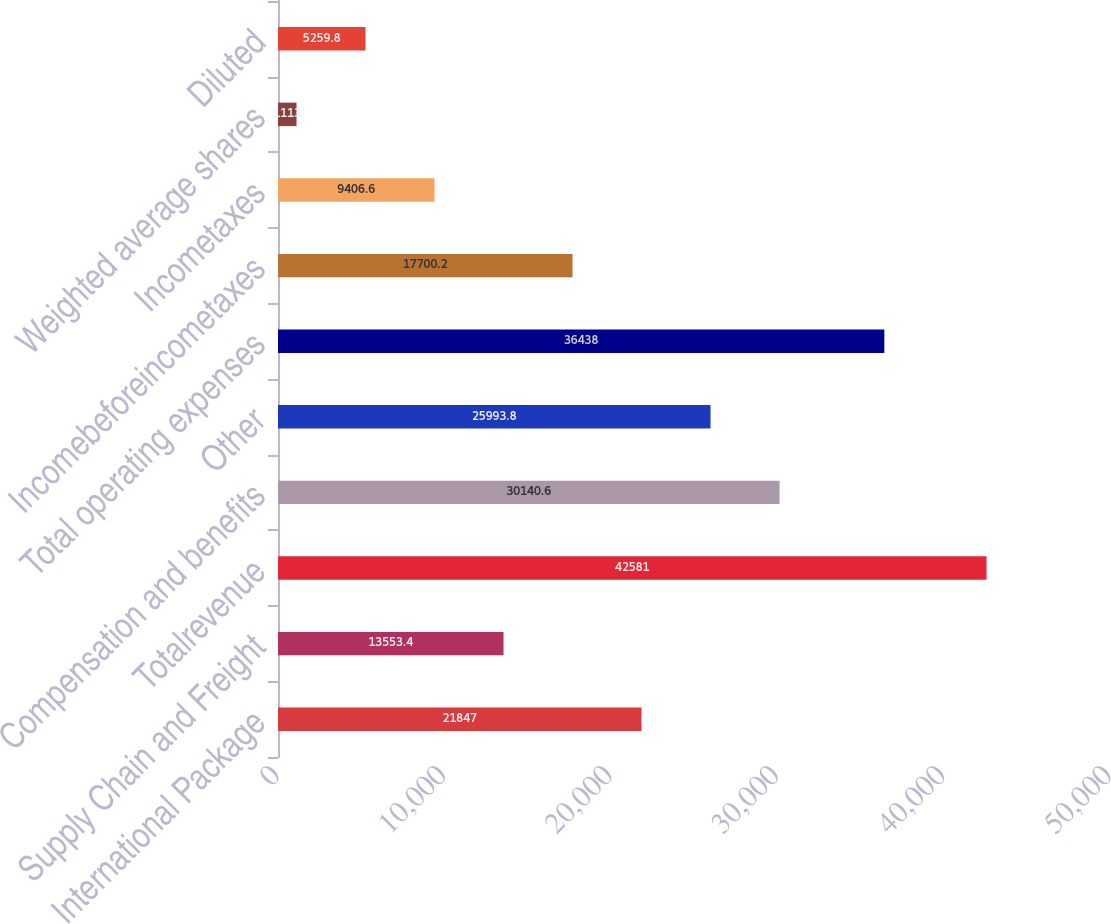<chart> <loc_0><loc_0><loc_500><loc_500><bar_chart><fcel>International Package<fcel>Supply Chain and Freight<fcel>Totalrevenue<fcel>Compensation and benefits<fcel>Other<fcel>Total operating expenses<fcel>Incomebeforeincometaxes<fcel>Incometaxes<fcel>Weighted average shares<fcel>Diluted<nl><fcel>21847<fcel>13553.4<fcel>42581<fcel>30140.6<fcel>25993.8<fcel>36438<fcel>17700.2<fcel>9406.6<fcel>1113<fcel>5259.8<nl></chart> 